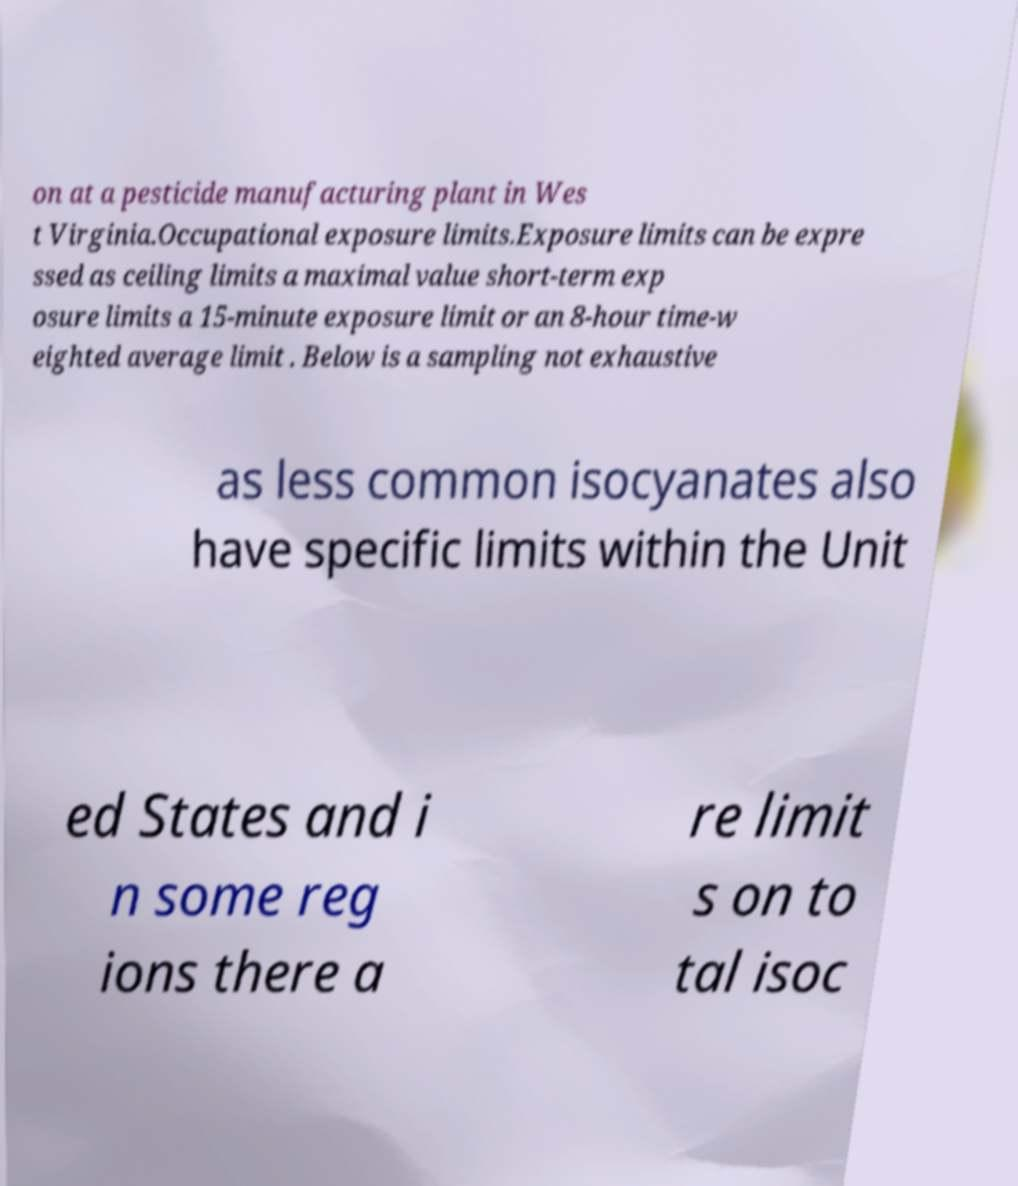There's text embedded in this image that I need extracted. Can you transcribe it verbatim? on at a pesticide manufacturing plant in Wes t Virginia.Occupational exposure limits.Exposure limits can be expre ssed as ceiling limits a maximal value short-term exp osure limits a 15-minute exposure limit or an 8-hour time-w eighted average limit . Below is a sampling not exhaustive as less common isocyanates also have specific limits within the Unit ed States and i n some reg ions there a re limit s on to tal isoc 